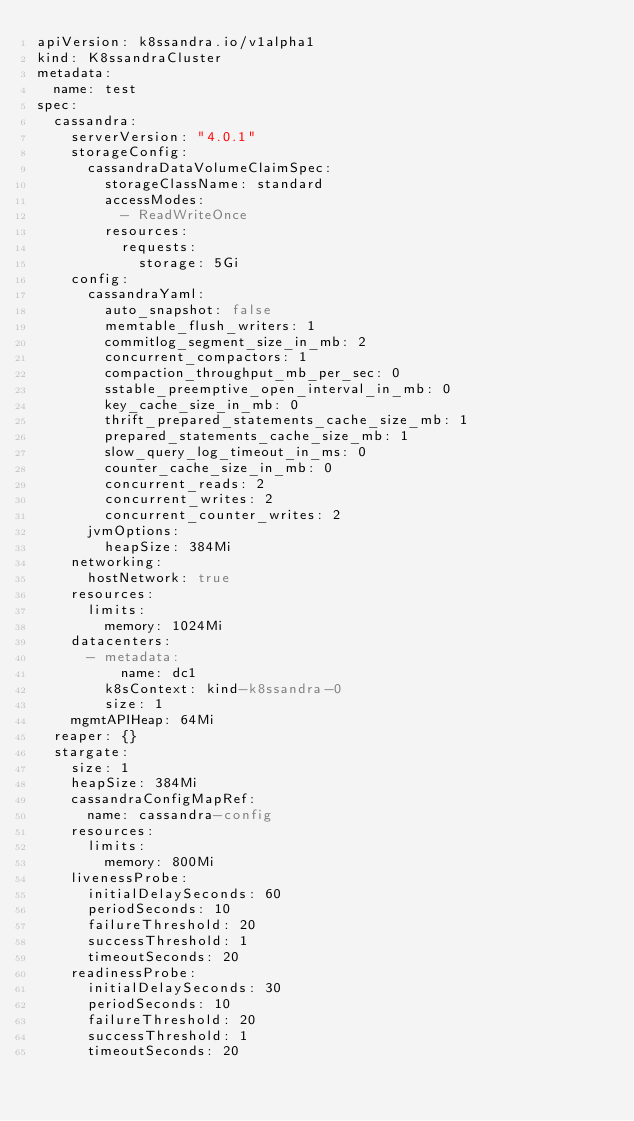Convert code to text. <code><loc_0><loc_0><loc_500><loc_500><_YAML_>apiVersion: k8ssandra.io/v1alpha1
kind: K8ssandraCluster
metadata:
  name: test
spec:
  cassandra:
    serverVersion: "4.0.1"
    storageConfig:
      cassandraDataVolumeClaimSpec:
        storageClassName: standard
        accessModes:
          - ReadWriteOnce
        resources:
          requests:
            storage: 5Gi
    config:
      cassandraYaml:
        auto_snapshot: false
        memtable_flush_writers: 1
        commitlog_segment_size_in_mb: 2
        concurrent_compactors: 1
        compaction_throughput_mb_per_sec: 0
        sstable_preemptive_open_interval_in_mb: 0
        key_cache_size_in_mb: 0
        thrift_prepared_statements_cache_size_mb: 1
        prepared_statements_cache_size_mb: 1
        slow_query_log_timeout_in_ms: 0
        counter_cache_size_in_mb: 0
        concurrent_reads: 2
        concurrent_writes: 2
        concurrent_counter_writes: 2
      jvmOptions:
        heapSize: 384Mi
    networking:
      hostNetwork: true
    resources:
      limits:
        memory: 1024Mi
    datacenters:
      - metadata:
          name: dc1
        k8sContext: kind-k8ssandra-0
        size: 1
    mgmtAPIHeap: 64Mi
  reaper: {}
  stargate:
    size: 1
    heapSize: 384Mi
    cassandraConfigMapRef:
      name: cassandra-config
    resources:
      limits:
        memory: 800Mi
    livenessProbe:
      initialDelaySeconds: 60
      periodSeconds: 10
      failureThreshold: 20
      successThreshold: 1
      timeoutSeconds: 20
    readinessProbe:
      initialDelaySeconds: 30
      periodSeconds: 10
      failureThreshold: 20
      successThreshold: 1
      timeoutSeconds: 20

</code> 